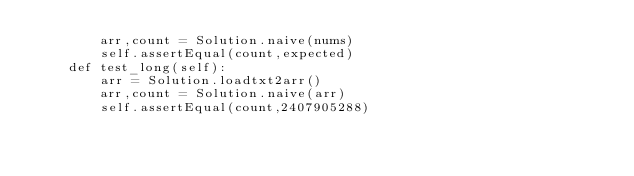<code> <loc_0><loc_0><loc_500><loc_500><_Python_>        arr,count = Solution.naive(nums)
        self.assertEqual(count,expected)
    def test_long(self):
        arr = Solution.loadtxt2arr()
        arr,count = Solution.naive(arr)
        self.assertEqual(count,2407905288)</code> 